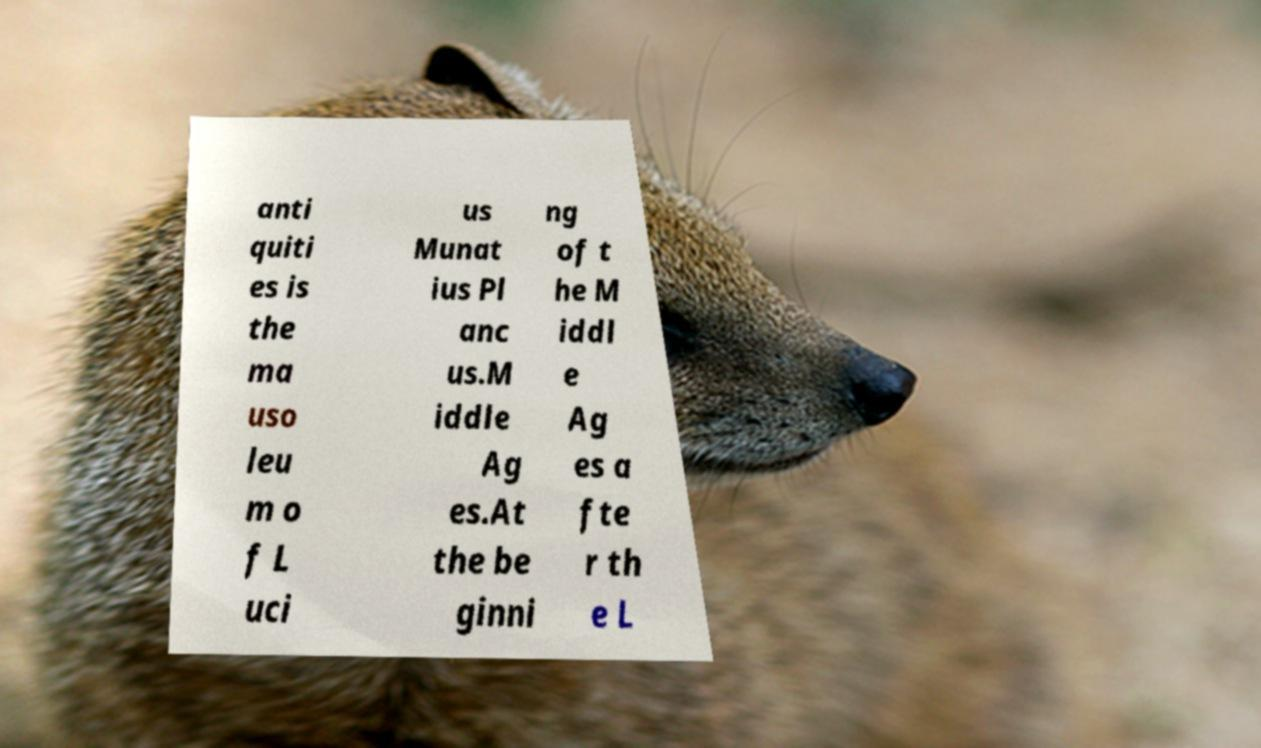Could you extract and type out the text from this image? anti quiti es is the ma uso leu m o f L uci us Munat ius Pl anc us.M iddle Ag es.At the be ginni ng of t he M iddl e Ag es a fte r th e L 